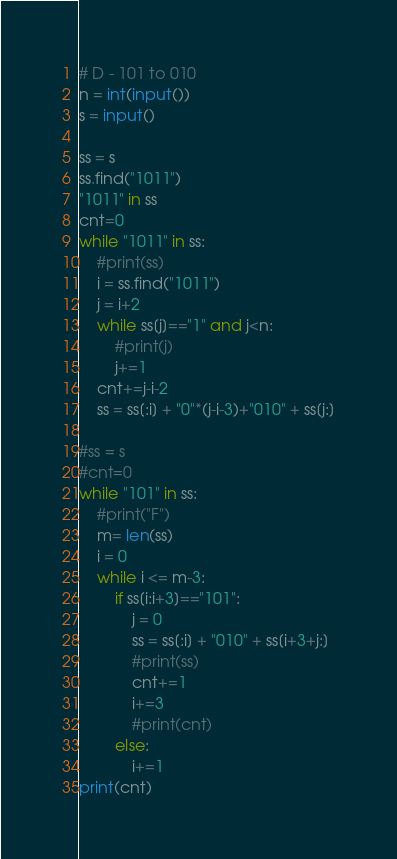Convert code to text. <code><loc_0><loc_0><loc_500><loc_500><_Python_># D - 101 to 010
n = int(input())
s = input()

ss = s
ss.find("1011")
"1011" in ss
cnt=0
while "1011" in ss:
    #print(ss)
    i = ss.find("1011")
    j = i+2
    while ss[j]=="1" and j<n:
        #print(j)
        j+=1
    cnt+=j-i-2
    ss = ss[:i] + "0"*(j-i-3)+"010" + ss[j:]

#ss = s
#cnt=0
while "101" in ss:
    #print("F")
    m= len(ss)
    i = 0
    while i <= m-3:
        if ss[i:i+3]=="101":
            j = 0
            ss = ss[:i] + "010" + ss[i+3+j:]
            #print(ss)
            cnt+=1
            i+=3
            #print(cnt)
        else:
            i+=1
print(cnt)</code> 